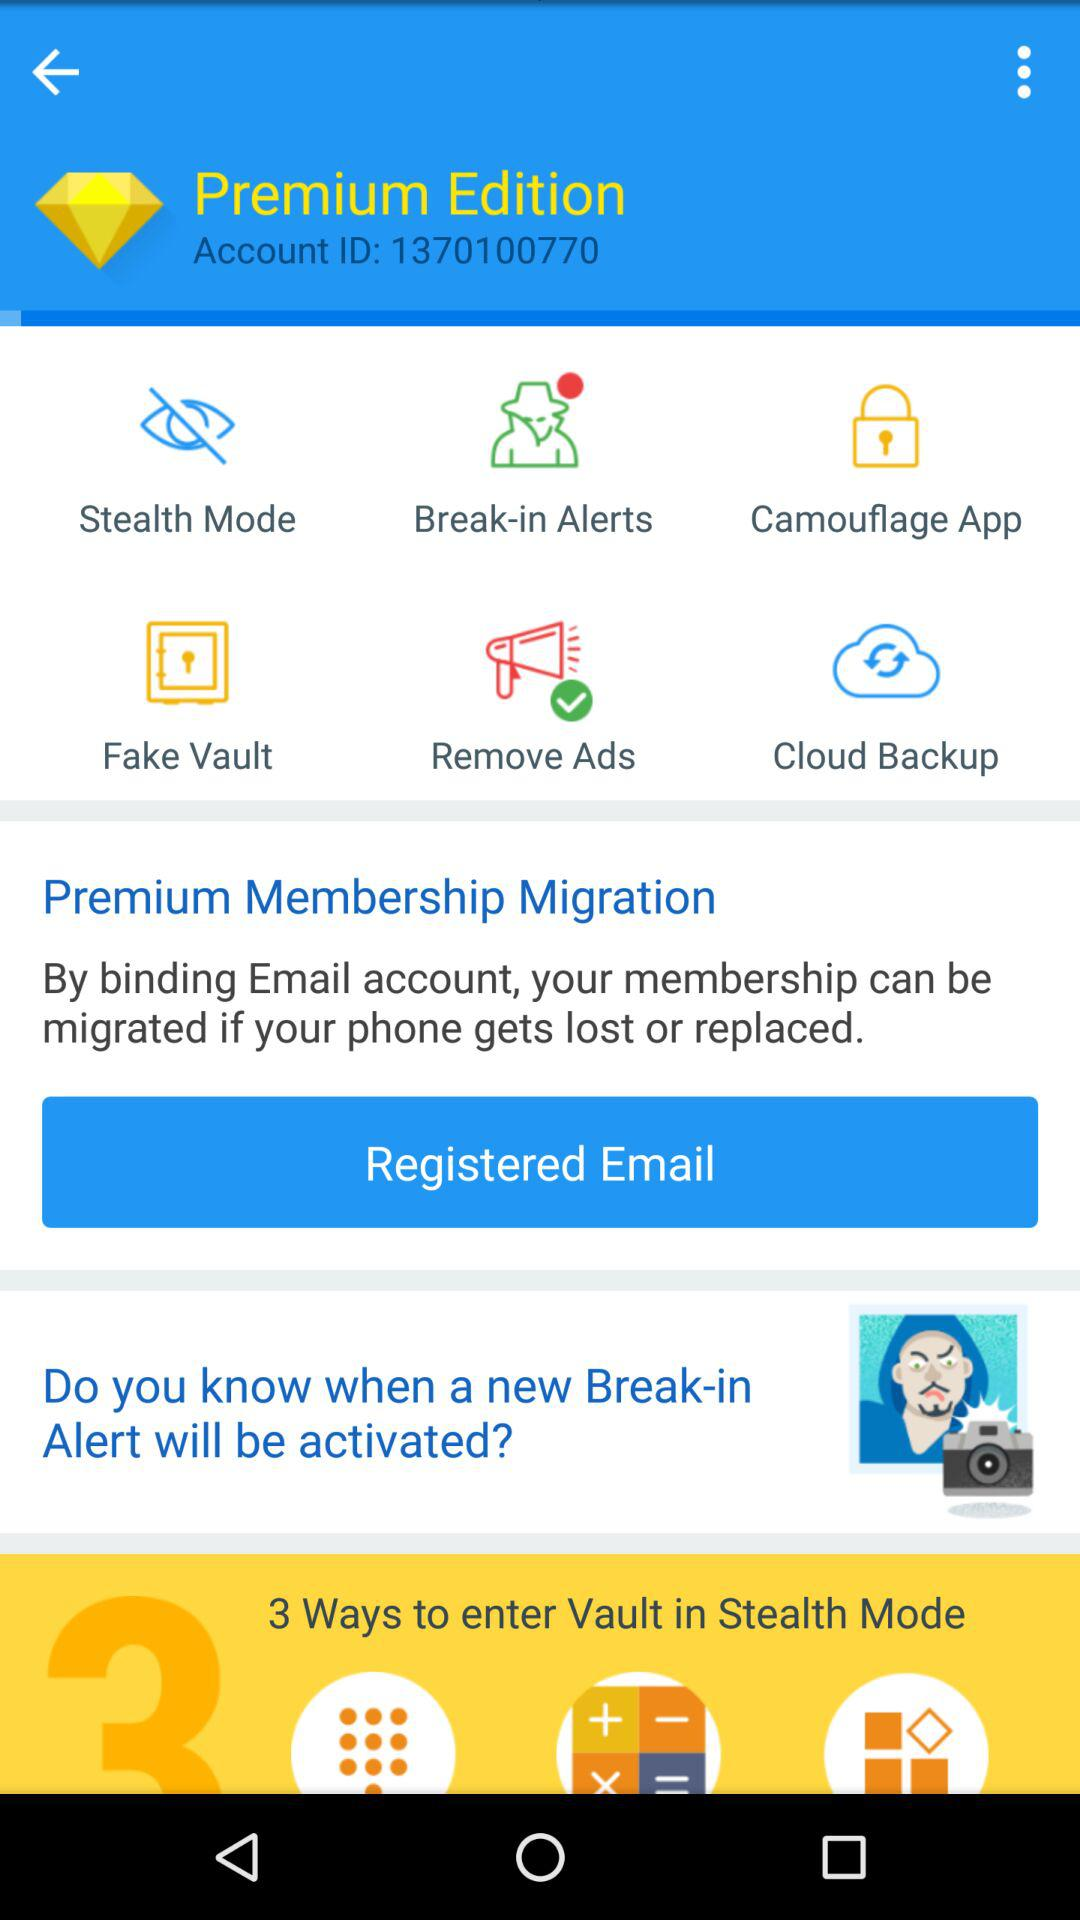How many features are there in total?
Answer the question using a single word or phrase. 6 